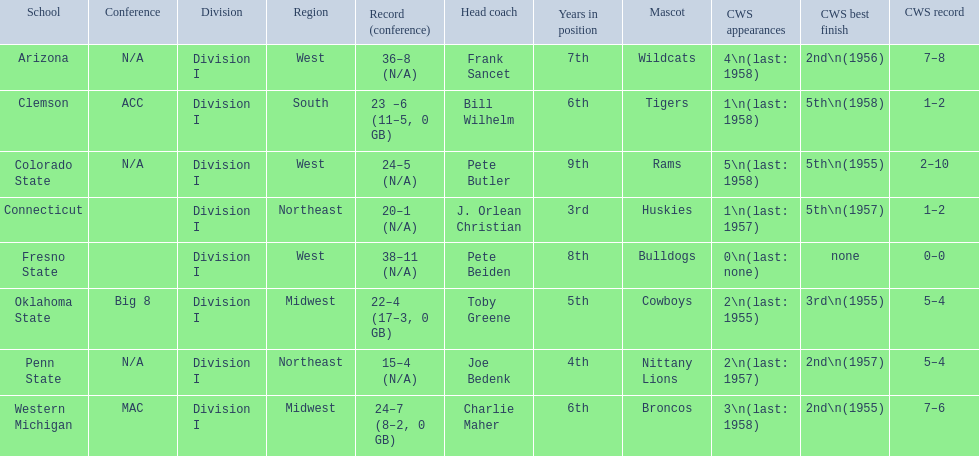What are all the schools? Arizona, Clemson, Colorado State, Connecticut, Fresno State, Oklahoma State, Penn State, Western Michigan. Which are clemson and western michigan? Clemson, Western Michigan. Of these, which has more cws appearances? Western Michigan. 